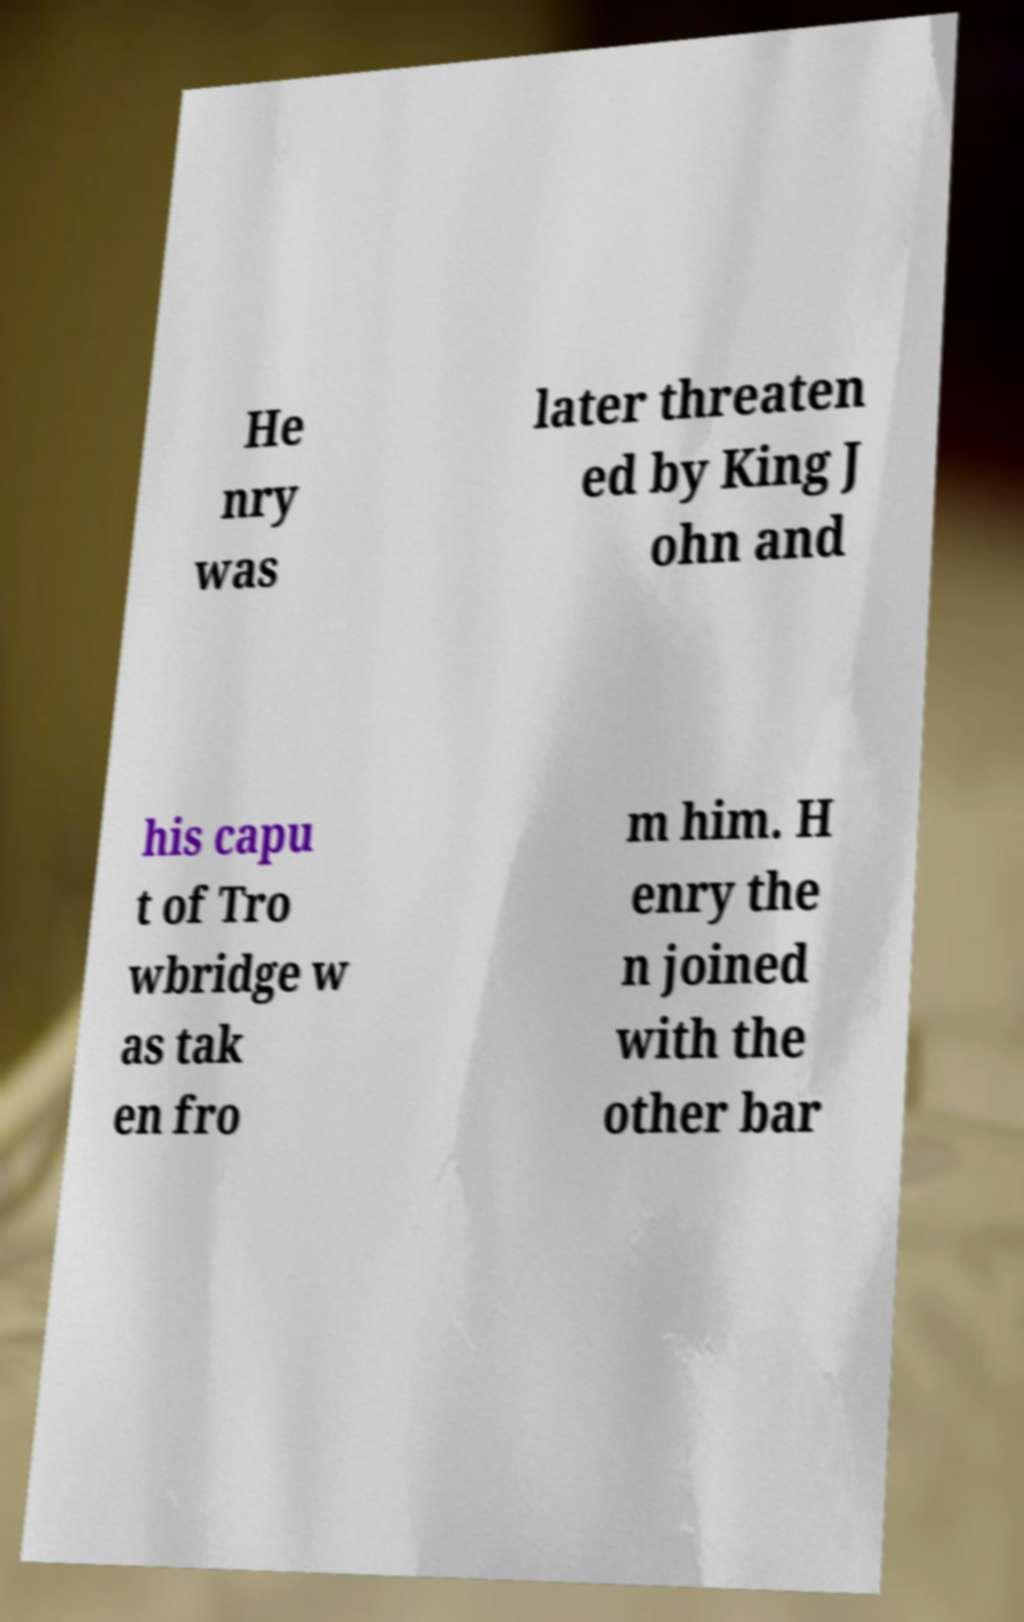Please identify and transcribe the text found in this image. He nry was later threaten ed by King J ohn and his capu t of Tro wbridge w as tak en fro m him. H enry the n joined with the other bar 